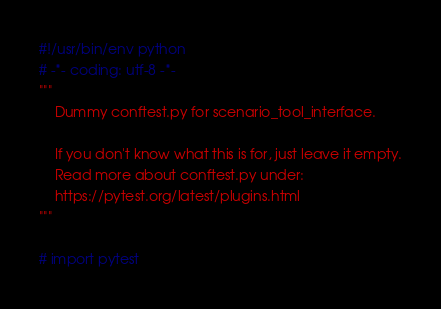<code> <loc_0><loc_0><loc_500><loc_500><_Python_>#!/usr/bin/env python
# -*- coding: utf-8 -*-
"""
    Dummy conftest.py for scenario_tool_interface.

    If you don't know what this is for, just leave it empty.
    Read more about conftest.py under:
    https://pytest.org/latest/plugins.html
"""

# import pytest
</code> 